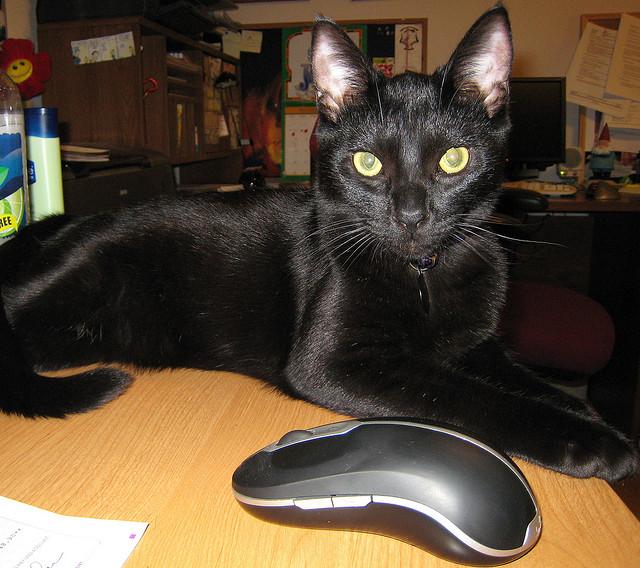Is this a wild animal?
Keep it brief. No. What color is the cat's eyes?
Give a very brief answer. Yellow. Is the cat playing with the computer mouse?
Concise answer only. No. Where is the cat?
Quick response, please. On desk. What bred of cat is this?
Write a very short answer. Siamese. Is this cat at the vet?
Quick response, please. No. 